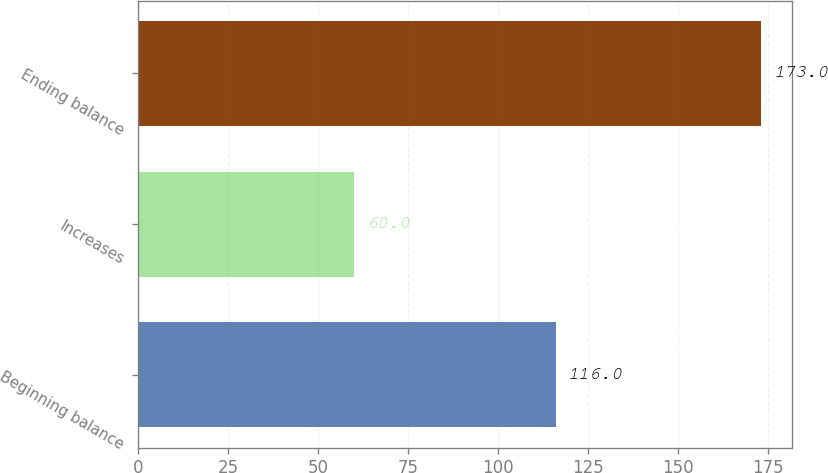Convert chart to OTSL. <chart><loc_0><loc_0><loc_500><loc_500><bar_chart><fcel>Beginning balance<fcel>Increases<fcel>Ending balance<nl><fcel>116<fcel>60<fcel>173<nl></chart> 